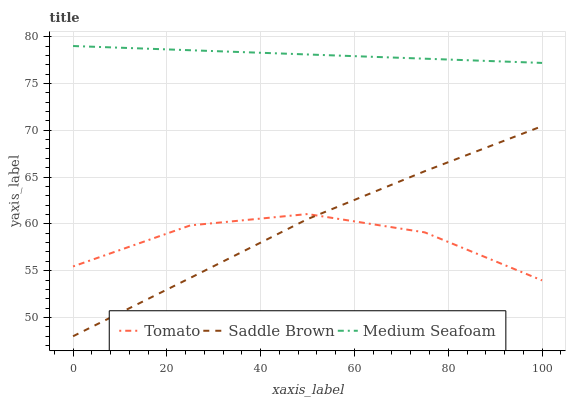Does Tomato have the minimum area under the curve?
Answer yes or no. Yes. Does Medium Seafoam have the maximum area under the curve?
Answer yes or no. Yes. Does Saddle Brown have the minimum area under the curve?
Answer yes or no. No. Does Saddle Brown have the maximum area under the curve?
Answer yes or no. No. Is Medium Seafoam the smoothest?
Answer yes or no. Yes. Is Tomato the roughest?
Answer yes or no. Yes. Is Saddle Brown the smoothest?
Answer yes or no. No. Is Saddle Brown the roughest?
Answer yes or no. No. Does Saddle Brown have the lowest value?
Answer yes or no. Yes. Does Medium Seafoam have the lowest value?
Answer yes or no. No. Does Medium Seafoam have the highest value?
Answer yes or no. Yes. Does Saddle Brown have the highest value?
Answer yes or no. No. Is Tomato less than Medium Seafoam?
Answer yes or no. Yes. Is Medium Seafoam greater than Saddle Brown?
Answer yes or no. Yes. Does Saddle Brown intersect Tomato?
Answer yes or no. Yes. Is Saddle Brown less than Tomato?
Answer yes or no. No. Is Saddle Brown greater than Tomato?
Answer yes or no. No. Does Tomato intersect Medium Seafoam?
Answer yes or no. No. 